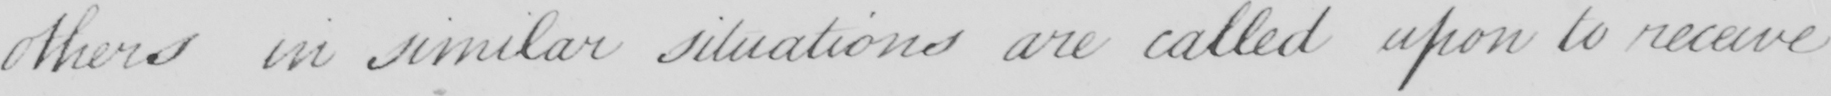What is written in this line of handwriting? others in similar situations are called upon to receive 